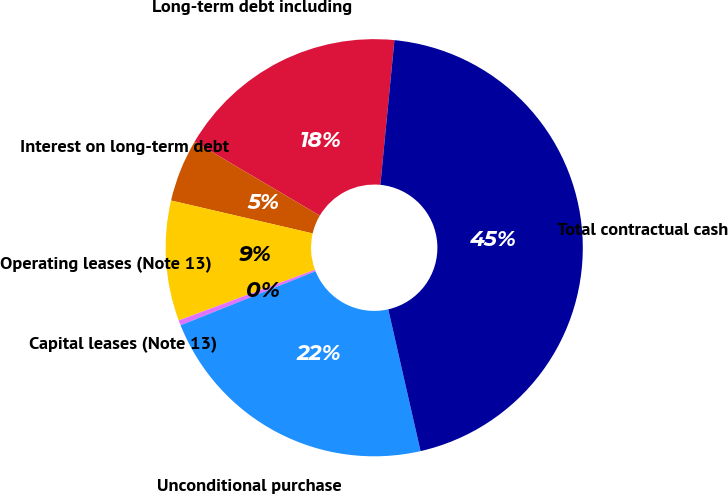Convert chart. <chart><loc_0><loc_0><loc_500><loc_500><pie_chart><fcel>Long-term debt including<fcel>Interest on long-term debt<fcel>Operating leases (Note 13)<fcel>Capital leases (Note 13)<fcel>Unconditional purchase<fcel>Total contractual cash<nl><fcel>18.06%<fcel>4.85%<fcel>9.3%<fcel>0.4%<fcel>22.5%<fcel>44.89%<nl></chart> 